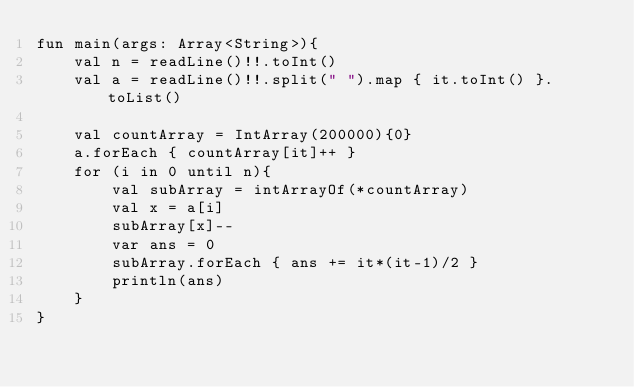<code> <loc_0><loc_0><loc_500><loc_500><_Kotlin_>fun main(args: Array<String>){
    val n = readLine()!!.toInt()
    val a = readLine()!!.split(" ").map { it.toInt() }.toList()

    val countArray = IntArray(200000){0}
    a.forEach { countArray[it]++ }
    for (i in 0 until n){
        val subArray = intArrayOf(*countArray)
        val x = a[i]
        subArray[x]--
        var ans = 0
        subArray.forEach { ans += it*(it-1)/2 }
        println(ans)
    }
}</code> 